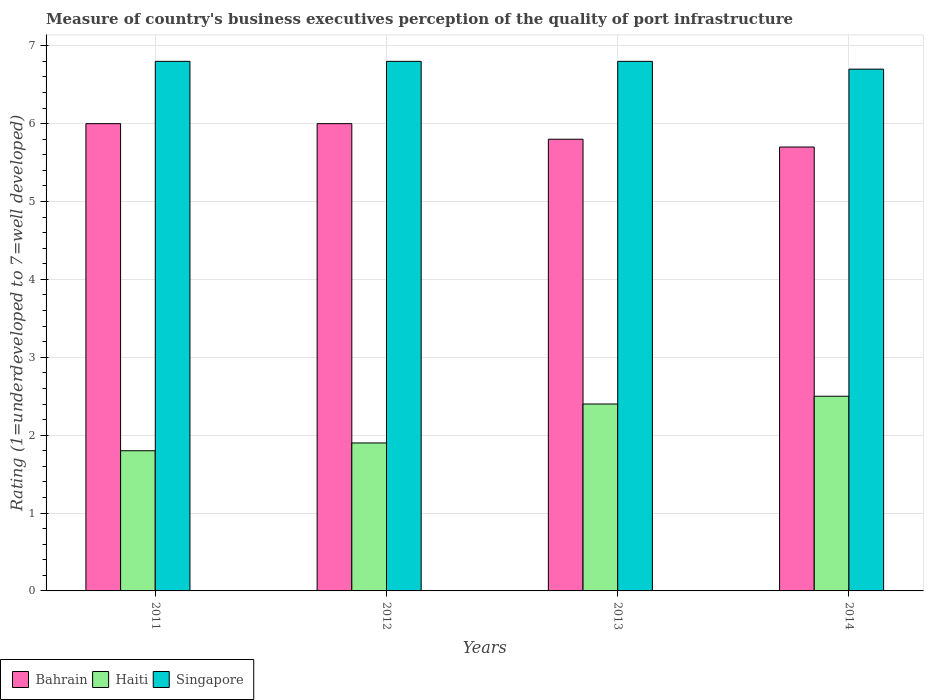How many groups of bars are there?
Provide a succinct answer. 4. Are the number of bars per tick equal to the number of legend labels?
Your answer should be compact. Yes. Are the number of bars on each tick of the X-axis equal?
Keep it short and to the point. Yes. How many bars are there on the 2nd tick from the left?
Your answer should be compact. 3. How many bars are there on the 4th tick from the right?
Your response must be concise. 3. In how many cases, is the number of bars for a given year not equal to the number of legend labels?
Give a very brief answer. 0. What is the ratings of the quality of port infrastructure in Bahrain in 2013?
Make the answer very short. 5.8. Across all years, what is the maximum ratings of the quality of port infrastructure in Singapore?
Offer a terse response. 6.8. Across all years, what is the minimum ratings of the quality of port infrastructure in Singapore?
Offer a terse response. 6.7. What is the difference between the ratings of the quality of port infrastructure in Singapore in 2011 and that in 2012?
Your response must be concise. 0. What is the average ratings of the quality of port infrastructure in Bahrain per year?
Your answer should be very brief. 5.88. In how many years, is the ratings of the quality of port infrastructure in Bahrain greater than 5.4?
Provide a short and direct response. 4. What is the ratio of the ratings of the quality of port infrastructure in Singapore in 2012 to that in 2013?
Offer a terse response. 1. Is the ratings of the quality of port infrastructure in Haiti in 2013 less than that in 2014?
Your response must be concise. Yes. Is the difference between the ratings of the quality of port infrastructure in Haiti in 2011 and 2012 greater than the difference between the ratings of the quality of port infrastructure in Bahrain in 2011 and 2012?
Make the answer very short. No. What is the difference between the highest and the lowest ratings of the quality of port infrastructure in Singapore?
Give a very brief answer. 0.1. What does the 3rd bar from the left in 2013 represents?
Ensure brevity in your answer.  Singapore. What does the 3rd bar from the right in 2012 represents?
Provide a succinct answer. Bahrain. Is it the case that in every year, the sum of the ratings of the quality of port infrastructure in Singapore and ratings of the quality of port infrastructure in Bahrain is greater than the ratings of the quality of port infrastructure in Haiti?
Offer a terse response. Yes. How many bars are there?
Offer a terse response. 12. Are all the bars in the graph horizontal?
Your answer should be very brief. No. How many years are there in the graph?
Provide a short and direct response. 4. Does the graph contain any zero values?
Provide a succinct answer. No. Does the graph contain grids?
Offer a very short reply. Yes. Where does the legend appear in the graph?
Ensure brevity in your answer.  Bottom left. How are the legend labels stacked?
Your answer should be compact. Horizontal. What is the title of the graph?
Your response must be concise. Measure of country's business executives perception of the quality of port infrastructure. Does "High income: OECD" appear as one of the legend labels in the graph?
Offer a very short reply. No. What is the label or title of the X-axis?
Give a very brief answer. Years. What is the label or title of the Y-axis?
Keep it short and to the point. Rating (1=underdeveloped to 7=well developed). What is the Rating (1=underdeveloped to 7=well developed) in Bahrain in 2012?
Offer a terse response. 6. What is the Rating (1=underdeveloped to 7=well developed) in Haiti in 2012?
Provide a succinct answer. 1.9. What is the Rating (1=underdeveloped to 7=well developed) in Singapore in 2012?
Provide a short and direct response. 6.8. What is the Rating (1=underdeveloped to 7=well developed) in Bahrain in 2013?
Your answer should be very brief. 5.8. What is the Rating (1=underdeveloped to 7=well developed) of Haiti in 2013?
Offer a terse response. 2.4. What is the Rating (1=underdeveloped to 7=well developed) in Singapore in 2013?
Keep it short and to the point. 6.8. What is the Rating (1=underdeveloped to 7=well developed) in Haiti in 2014?
Provide a succinct answer. 2.5. What is the Rating (1=underdeveloped to 7=well developed) in Singapore in 2014?
Your response must be concise. 6.7. Across all years, what is the maximum Rating (1=underdeveloped to 7=well developed) of Bahrain?
Keep it short and to the point. 6. Across all years, what is the maximum Rating (1=underdeveloped to 7=well developed) of Singapore?
Offer a terse response. 6.8. Across all years, what is the minimum Rating (1=underdeveloped to 7=well developed) in Haiti?
Your response must be concise. 1.8. What is the total Rating (1=underdeveloped to 7=well developed) in Bahrain in the graph?
Provide a short and direct response. 23.5. What is the total Rating (1=underdeveloped to 7=well developed) of Haiti in the graph?
Provide a succinct answer. 8.6. What is the total Rating (1=underdeveloped to 7=well developed) of Singapore in the graph?
Offer a terse response. 27.1. What is the difference between the Rating (1=underdeveloped to 7=well developed) in Bahrain in 2011 and that in 2012?
Ensure brevity in your answer.  0. What is the difference between the Rating (1=underdeveloped to 7=well developed) of Singapore in 2011 and that in 2012?
Your answer should be very brief. 0. What is the difference between the Rating (1=underdeveloped to 7=well developed) of Haiti in 2011 and that in 2013?
Your answer should be compact. -0.6. What is the difference between the Rating (1=underdeveloped to 7=well developed) in Singapore in 2011 and that in 2013?
Offer a very short reply. 0. What is the difference between the Rating (1=underdeveloped to 7=well developed) of Bahrain in 2011 and that in 2014?
Your answer should be very brief. 0.3. What is the difference between the Rating (1=underdeveloped to 7=well developed) of Haiti in 2011 and that in 2014?
Provide a short and direct response. -0.7. What is the difference between the Rating (1=underdeveloped to 7=well developed) in Bahrain in 2012 and that in 2014?
Offer a terse response. 0.3. What is the difference between the Rating (1=underdeveloped to 7=well developed) of Singapore in 2012 and that in 2014?
Provide a short and direct response. 0.1. What is the difference between the Rating (1=underdeveloped to 7=well developed) in Bahrain in 2013 and that in 2014?
Provide a short and direct response. 0.1. What is the difference between the Rating (1=underdeveloped to 7=well developed) of Haiti in 2013 and that in 2014?
Your response must be concise. -0.1. What is the difference between the Rating (1=underdeveloped to 7=well developed) in Singapore in 2013 and that in 2014?
Offer a very short reply. 0.1. What is the difference between the Rating (1=underdeveloped to 7=well developed) in Bahrain in 2011 and the Rating (1=underdeveloped to 7=well developed) in Singapore in 2012?
Your answer should be very brief. -0.8. What is the difference between the Rating (1=underdeveloped to 7=well developed) of Haiti in 2011 and the Rating (1=underdeveloped to 7=well developed) of Singapore in 2012?
Your answer should be compact. -5. What is the difference between the Rating (1=underdeveloped to 7=well developed) in Bahrain in 2011 and the Rating (1=underdeveloped to 7=well developed) in Singapore in 2013?
Provide a short and direct response. -0.8. What is the difference between the Rating (1=underdeveloped to 7=well developed) of Bahrain in 2011 and the Rating (1=underdeveloped to 7=well developed) of Haiti in 2014?
Your response must be concise. 3.5. What is the difference between the Rating (1=underdeveloped to 7=well developed) in Bahrain in 2011 and the Rating (1=underdeveloped to 7=well developed) in Singapore in 2014?
Provide a short and direct response. -0.7. What is the difference between the Rating (1=underdeveloped to 7=well developed) of Bahrain in 2012 and the Rating (1=underdeveloped to 7=well developed) of Haiti in 2014?
Offer a terse response. 3.5. What is the difference between the Rating (1=underdeveloped to 7=well developed) of Haiti in 2012 and the Rating (1=underdeveloped to 7=well developed) of Singapore in 2014?
Give a very brief answer. -4.8. What is the difference between the Rating (1=underdeveloped to 7=well developed) in Bahrain in 2013 and the Rating (1=underdeveloped to 7=well developed) in Haiti in 2014?
Your response must be concise. 3.3. What is the difference between the Rating (1=underdeveloped to 7=well developed) in Bahrain in 2013 and the Rating (1=underdeveloped to 7=well developed) in Singapore in 2014?
Offer a terse response. -0.9. What is the difference between the Rating (1=underdeveloped to 7=well developed) in Haiti in 2013 and the Rating (1=underdeveloped to 7=well developed) in Singapore in 2014?
Your response must be concise. -4.3. What is the average Rating (1=underdeveloped to 7=well developed) in Bahrain per year?
Your response must be concise. 5.88. What is the average Rating (1=underdeveloped to 7=well developed) in Haiti per year?
Offer a terse response. 2.15. What is the average Rating (1=underdeveloped to 7=well developed) of Singapore per year?
Keep it short and to the point. 6.78. In the year 2011, what is the difference between the Rating (1=underdeveloped to 7=well developed) in Bahrain and Rating (1=underdeveloped to 7=well developed) in Singapore?
Offer a terse response. -0.8. In the year 2011, what is the difference between the Rating (1=underdeveloped to 7=well developed) of Haiti and Rating (1=underdeveloped to 7=well developed) of Singapore?
Keep it short and to the point. -5. In the year 2012, what is the difference between the Rating (1=underdeveloped to 7=well developed) in Bahrain and Rating (1=underdeveloped to 7=well developed) in Singapore?
Your response must be concise. -0.8. In the year 2014, what is the difference between the Rating (1=underdeveloped to 7=well developed) of Bahrain and Rating (1=underdeveloped to 7=well developed) of Haiti?
Make the answer very short. 3.2. In the year 2014, what is the difference between the Rating (1=underdeveloped to 7=well developed) of Bahrain and Rating (1=underdeveloped to 7=well developed) of Singapore?
Ensure brevity in your answer.  -1. In the year 2014, what is the difference between the Rating (1=underdeveloped to 7=well developed) in Haiti and Rating (1=underdeveloped to 7=well developed) in Singapore?
Provide a short and direct response. -4.2. What is the ratio of the Rating (1=underdeveloped to 7=well developed) of Bahrain in 2011 to that in 2012?
Keep it short and to the point. 1. What is the ratio of the Rating (1=underdeveloped to 7=well developed) in Haiti in 2011 to that in 2012?
Keep it short and to the point. 0.95. What is the ratio of the Rating (1=underdeveloped to 7=well developed) in Singapore in 2011 to that in 2012?
Provide a short and direct response. 1. What is the ratio of the Rating (1=underdeveloped to 7=well developed) in Bahrain in 2011 to that in 2013?
Your answer should be very brief. 1.03. What is the ratio of the Rating (1=underdeveloped to 7=well developed) of Haiti in 2011 to that in 2013?
Keep it short and to the point. 0.75. What is the ratio of the Rating (1=underdeveloped to 7=well developed) in Bahrain in 2011 to that in 2014?
Offer a terse response. 1.05. What is the ratio of the Rating (1=underdeveloped to 7=well developed) in Haiti in 2011 to that in 2014?
Ensure brevity in your answer.  0.72. What is the ratio of the Rating (1=underdeveloped to 7=well developed) of Singapore in 2011 to that in 2014?
Offer a terse response. 1.01. What is the ratio of the Rating (1=underdeveloped to 7=well developed) in Bahrain in 2012 to that in 2013?
Offer a very short reply. 1.03. What is the ratio of the Rating (1=underdeveloped to 7=well developed) in Haiti in 2012 to that in 2013?
Give a very brief answer. 0.79. What is the ratio of the Rating (1=underdeveloped to 7=well developed) in Singapore in 2012 to that in 2013?
Your response must be concise. 1. What is the ratio of the Rating (1=underdeveloped to 7=well developed) of Bahrain in 2012 to that in 2014?
Your answer should be compact. 1.05. What is the ratio of the Rating (1=underdeveloped to 7=well developed) of Haiti in 2012 to that in 2014?
Ensure brevity in your answer.  0.76. What is the ratio of the Rating (1=underdeveloped to 7=well developed) in Singapore in 2012 to that in 2014?
Your response must be concise. 1.01. What is the ratio of the Rating (1=underdeveloped to 7=well developed) in Bahrain in 2013 to that in 2014?
Offer a very short reply. 1.02. What is the ratio of the Rating (1=underdeveloped to 7=well developed) in Singapore in 2013 to that in 2014?
Ensure brevity in your answer.  1.01. What is the difference between the highest and the lowest Rating (1=underdeveloped to 7=well developed) of Singapore?
Provide a short and direct response. 0.1. 